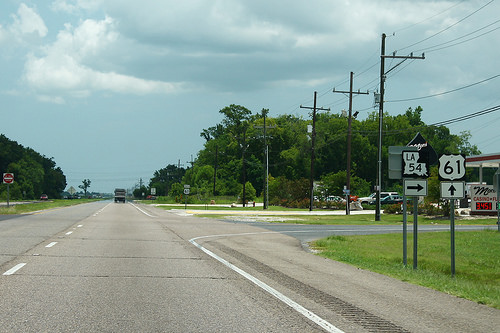<image>
Can you confirm if the sign board is in front of the trees? Yes. The sign board is positioned in front of the trees, appearing closer to the camera viewpoint. 